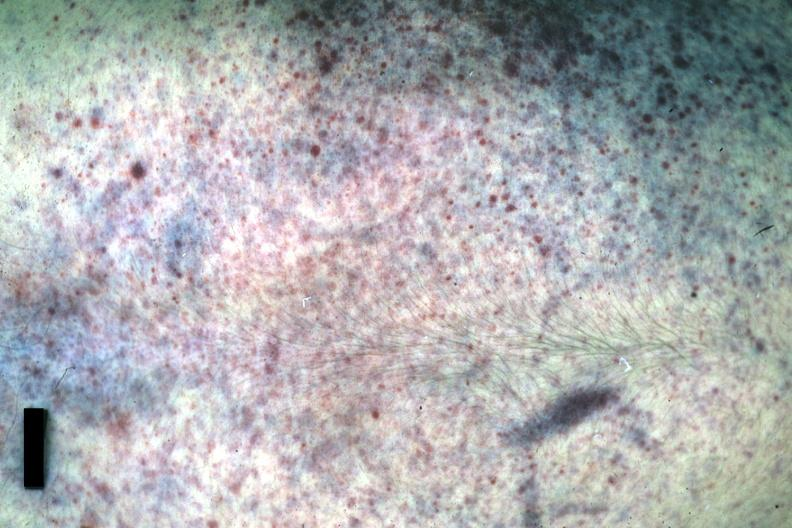was hematoma anterior or posterior?
Answer the question using a single word or phrase. No 